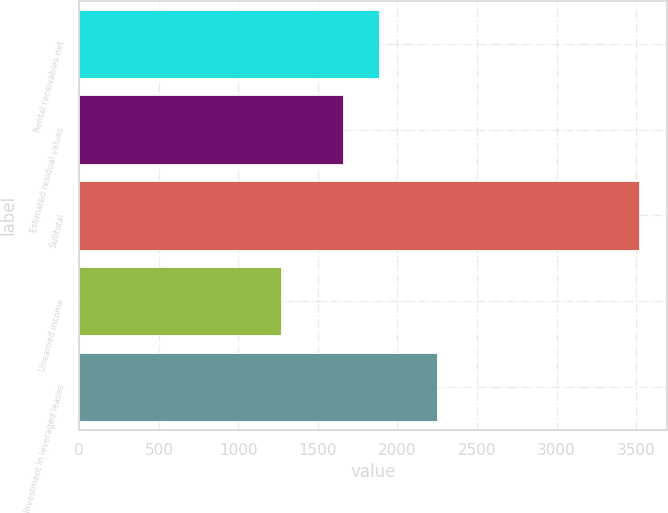Convert chart to OTSL. <chart><loc_0><loc_0><loc_500><loc_500><bar_chart><fcel>Rental receivables net<fcel>Estimated residual values<fcel>Subtotal<fcel>Unearned income<fcel>Investment in leveraged leases<nl><fcel>1881.8<fcel>1657<fcel>3516<fcel>1268<fcel>2248<nl></chart> 